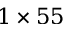Convert formula to latex. <formula><loc_0><loc_0><loc_500><loc_500>1 \times 5 5</formula> 